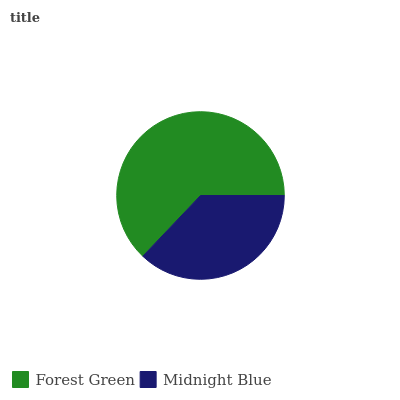Is Midnight Blue the minimum?
Answer yes or no. Yes. Is Forest Green the maximum?
Answer yes or no. Yes. Is Midnight Blue the maximum?
Answer yes or no. No. Is Forest Green greater than Midnight Blue?
Answer yes or no. Yes. Is Midnight Blue less than Forest Green?
Answer yes or no. Yes. Is Midnight Blue greater than Forest Green?
Answer yes or no. No. Is Forest Green less than Midnight Blue?
Answer yes or no. No. Is Forest Green the high median?
Answer yes or no. Yes. Is Midnight Blue the low median?
Answer yes or no. Yes. Is Midnight Blue the high median?
Answer yes or no. No. Is Forest Green the low median?
Answer yes or no. No. 